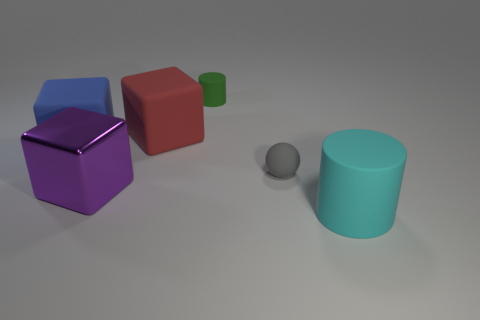Subtract all large rubber cubes. How many cubes are left? 1 Add 3 cyan matte objects. How many objects exist? 9 Add 3 small green cylinders. How many small green cylinders are left? 4 Add 4 brown spheres. How many brown spheres exist? 4 Subtract all cyan cylinders. How many cylinders are left? 1 Subtract 1 green cylinders. How many objects are left? 5 Subtract all spheres. How many objects are left? 5 Subtract 1 cubes. How many cubes are left? 2 Subtract all red blocks. Subtract all brown cylinders. How many blocks are left? 2 Subtract all green cylinders. How many cyan balls are left? 0 